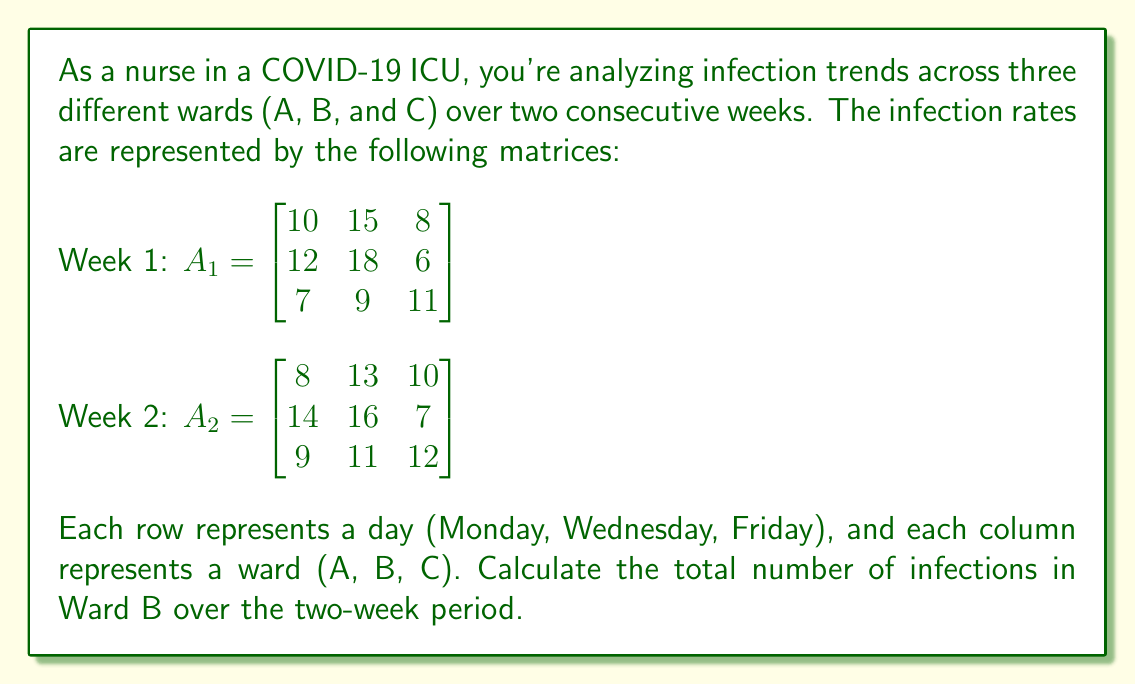Teach me how to tackle this problem. To solve this problem, we need to follow these steps:

1) Identify the column representing Ward B in both matrices:
   For both $A_1$ and $A_2$, Ward B is represented by the second column.

2) Extract the Ward B columns from both matrices:
   From $A_1$: $\begin{bmatrix} 15 \\ 18 \\ 9 \end{bmatrix}$
   From $A_2$: $\begin{bmatrix} 13 \\ 16 \\ 11 \end{bmatrix}$

3) Add these two column vectors:
   $\begin{bmatrix} 15 \\ 18 \\ 9 \end{bmatrix} + \begin{bmatrix} 13 \\ 16 \\ 11 \end{bmatrix} = \begin{bmatrix} 28 \\ 34 \\ 20 \end{bmatrix}$

4) Sum all elements in the resulting vector:
   $28 + 34 + 20 = 82$

Therefore, the total number of infections in Ward B over the two-week period is 82.
Answer: 82 